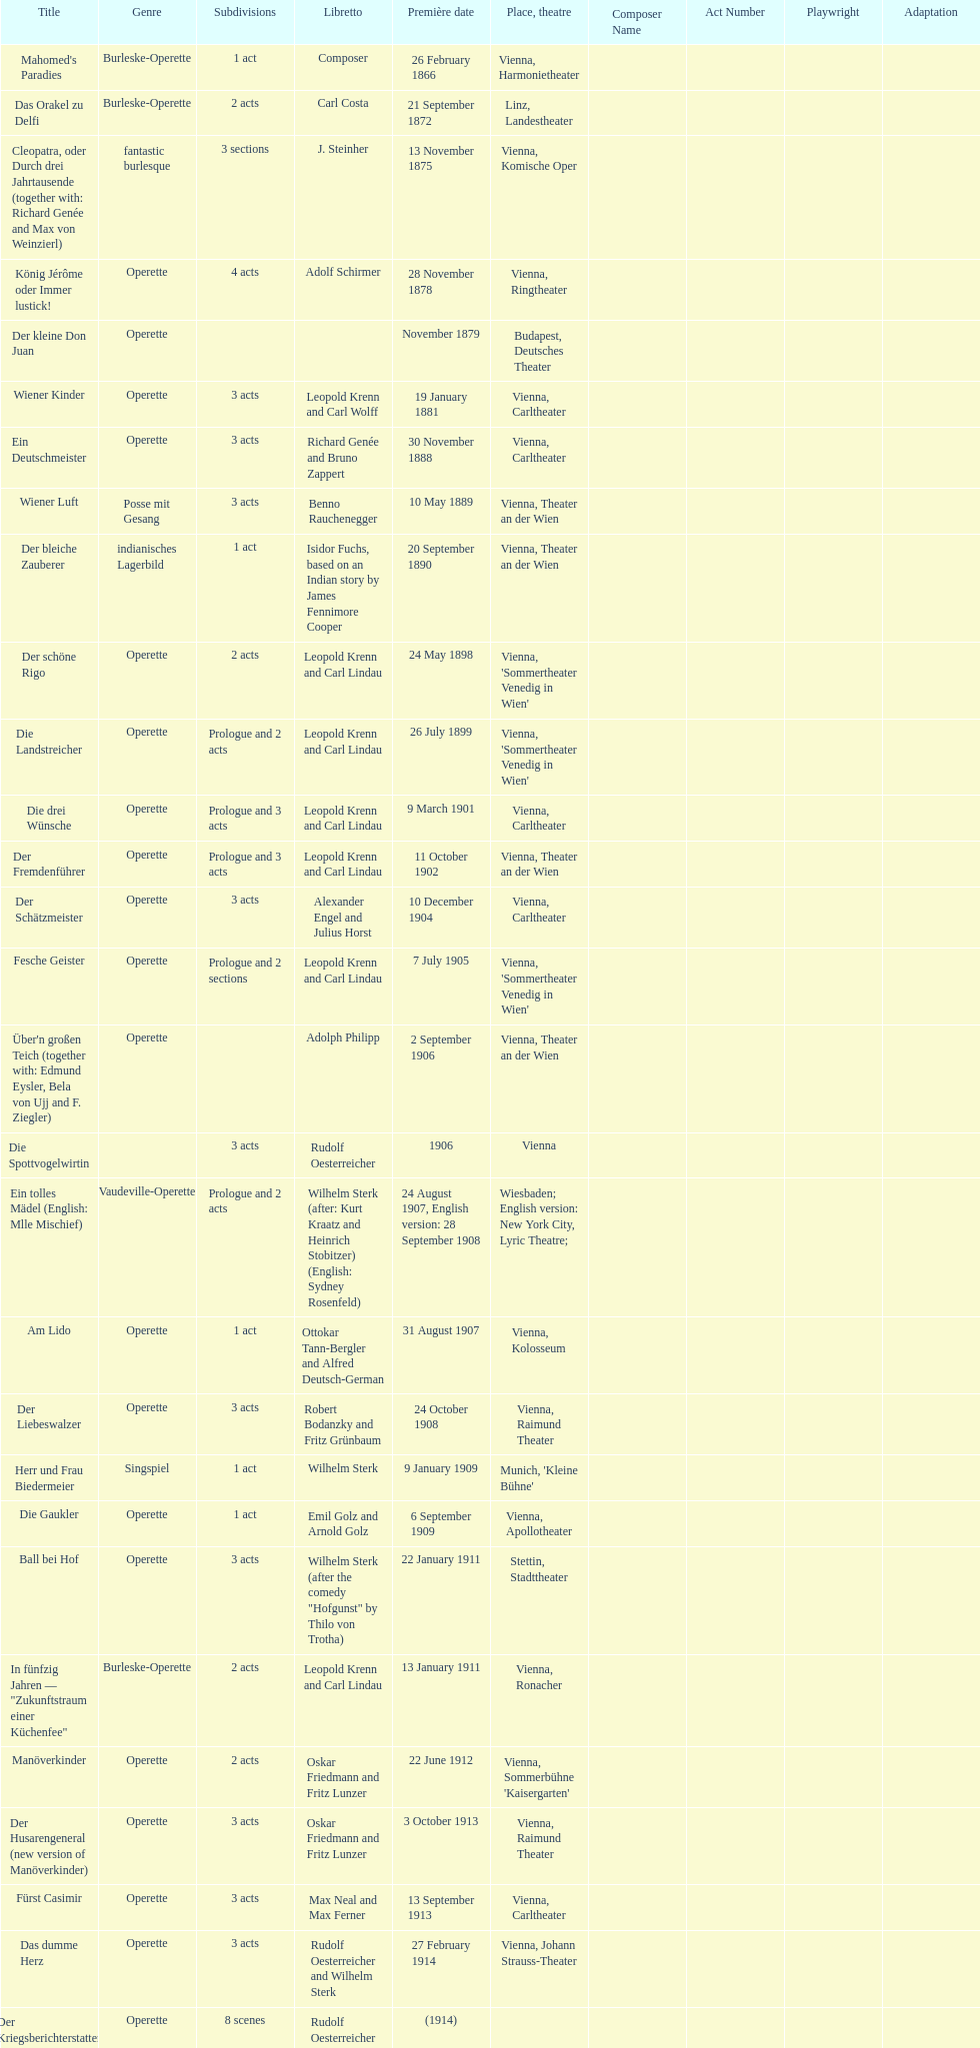In which city did the most operettas premiere? Vienna. 